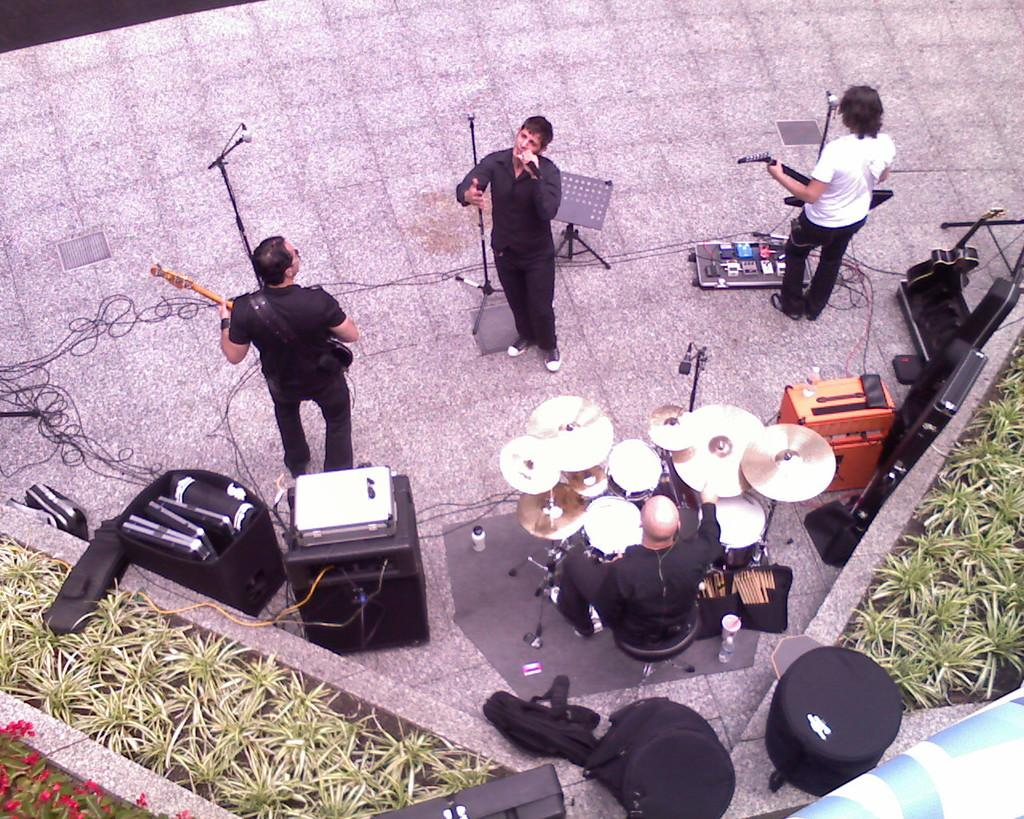What are the persons in the image doing? The persons in the image are playing musical instruments. What else can be seen in the image besides the persons playing instruments? There are plants visible in the image. What type of bun is being used as a drumstick in the image? There is no bun or drumstick present in the image; the persons are playing musical instruments with their hands or traditional drumsticks. 